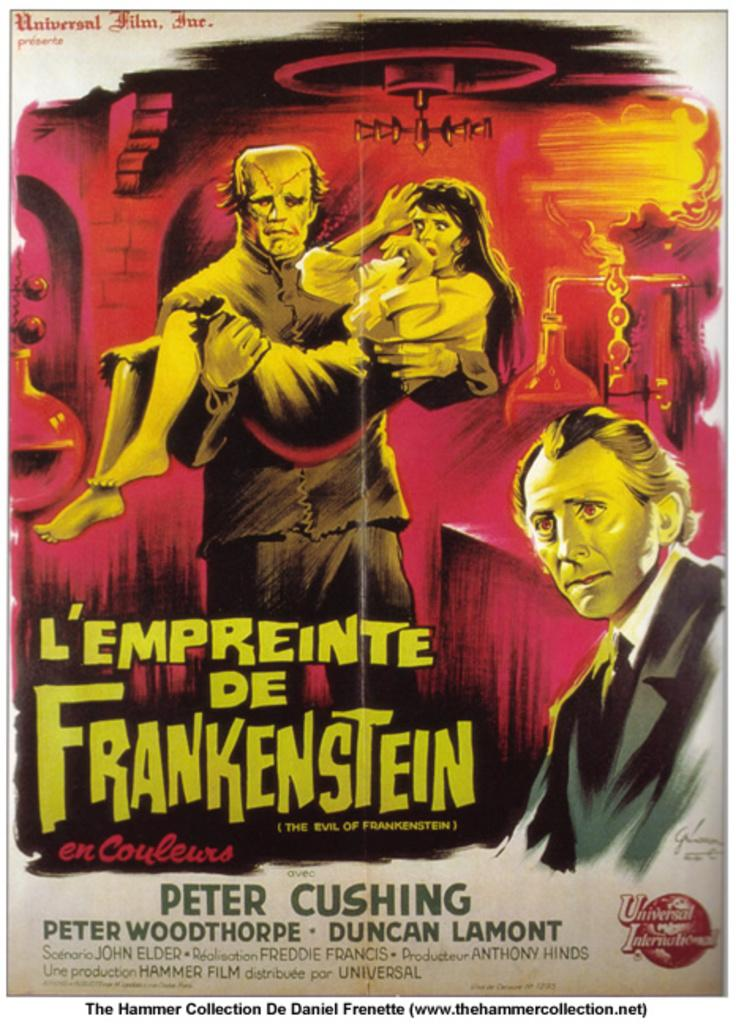<image>
Offer a succinct explanation of the picture presented. A poster for a movie featuring Peter Woodthorpe and Duncan Lamont ha an image of Frankenstein. 